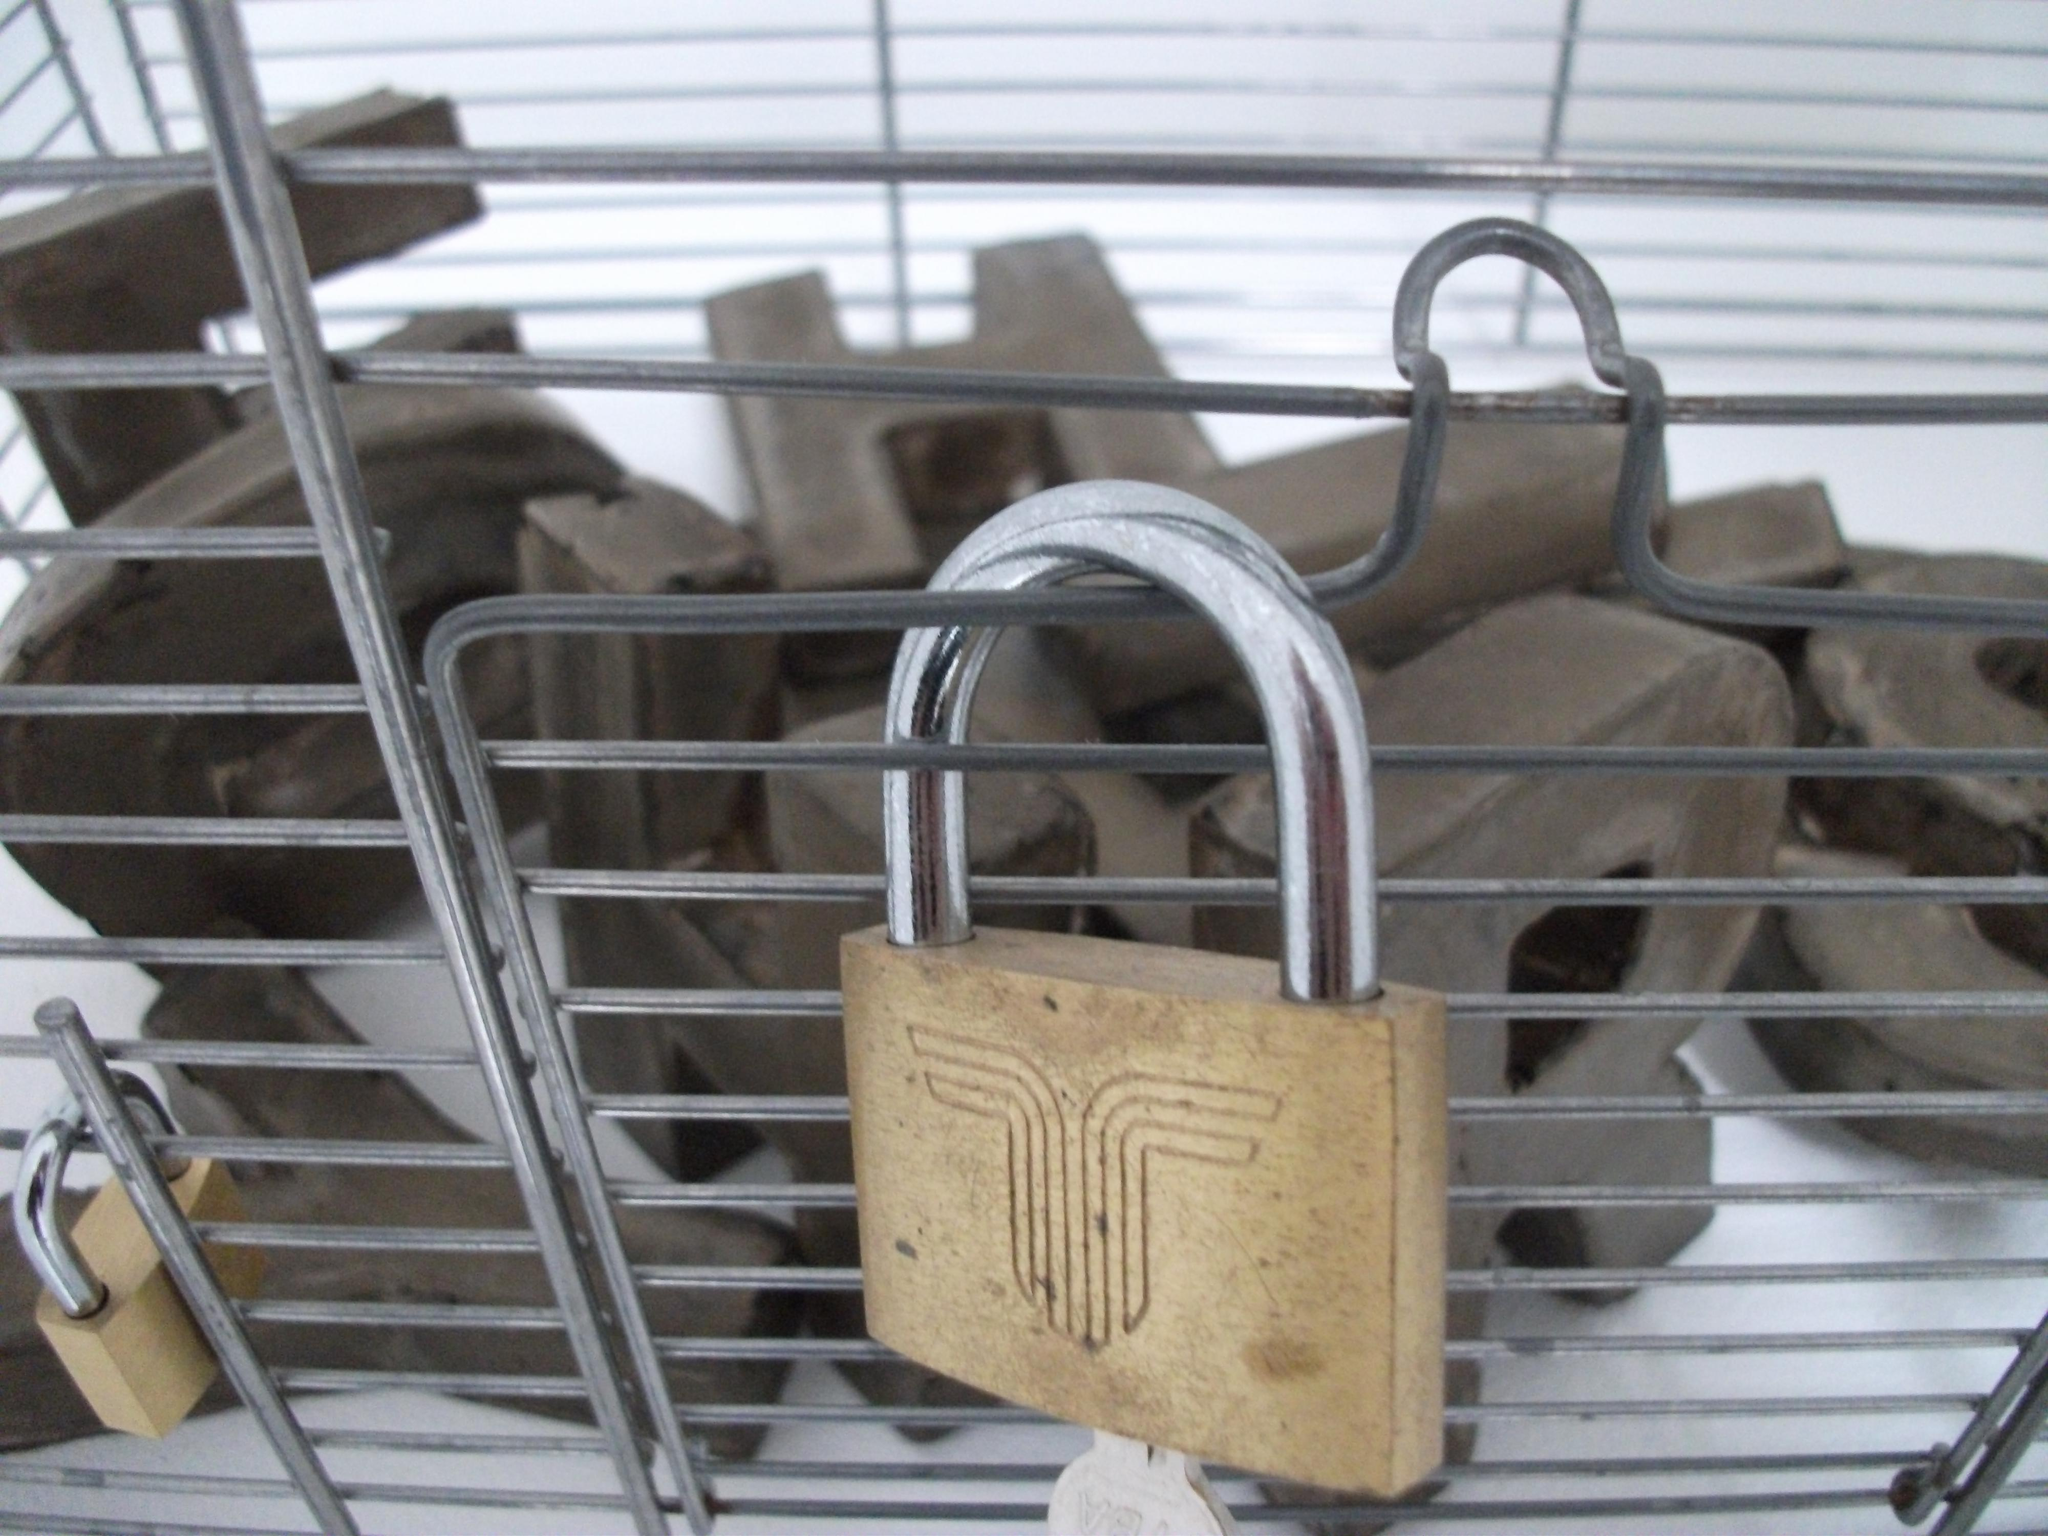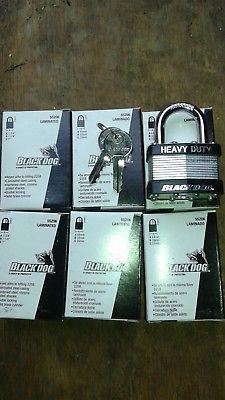The first image is the image on the left, the second image is the image on the right. Considering the images on both sides, is "there are newly never opened locks in packaging" valid? Answer yes or no. Yes. The first image is the image on the left, the second image is the image on the right. Given the left and right images, does the statement "The leftmost image contains exactly 3 tarnished old locks, not brand new or in packages." hold true? Answer yes or no. No. 